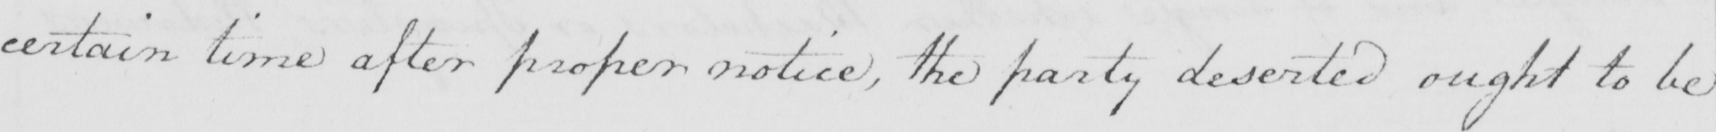Please transcribe the handwritten text in this image. certain time after proper notice , the party deserted ought to be 